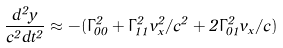Convert formula to latex. <formula><loc_0><loc_0><loc_500><loc_500>\frac { d ^ { 2 } y } { c ^ { 2 } d t ^ { 2 } } \approx - ( \Gamma ^ { 2 } _ { 0 0 } + \Gamma ^ { 2 } _ { 1 1 } v _ { x } ^ { 2 } / c ^ { 2 } + 2 \Gamma ^ { 2 } _ { 0 1 } v _ { x } / c )</formula> 